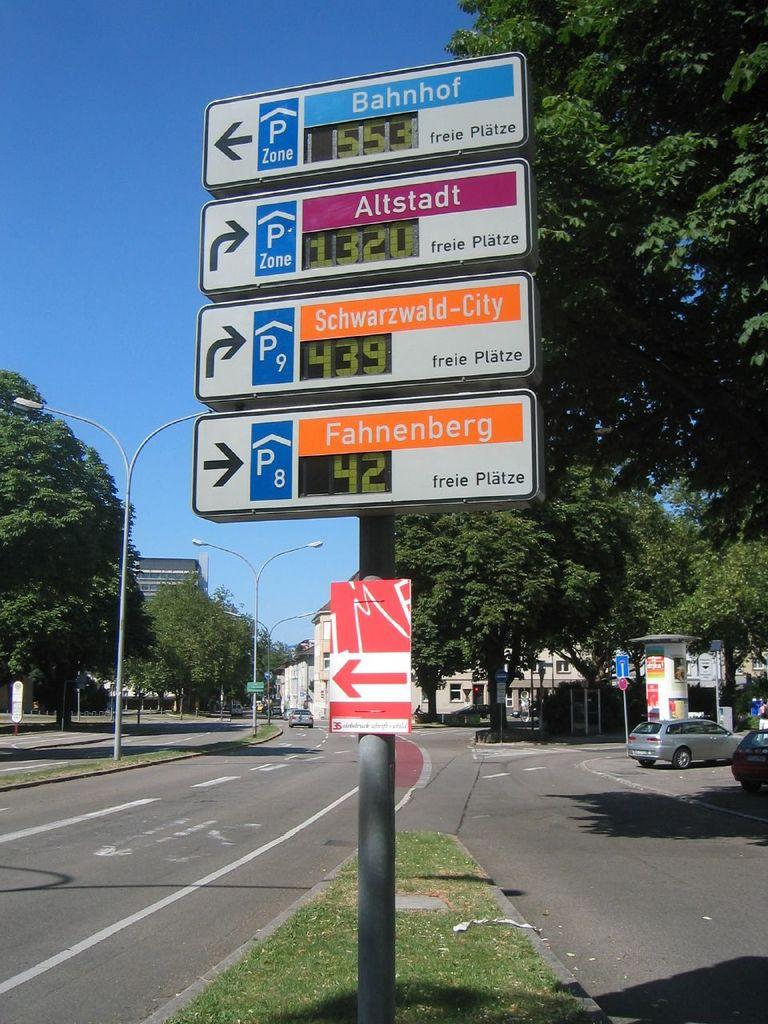What is the main structure in the image? There is a pole with boards attached to it in the image. What can be seen in the background of the image? There is a building, trees, vehicles on the roads, street lights, and the sky visible in the background of the image. What type of vegetation is present in the image? Grass is present in the image. What type of bells can be heard ringing in the image? There are no bells present in the image, and therefore no sound can be heard. 